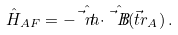Convert formula to latex. <formula><loc_0><loc_0><loc_500><loc_500>\hat { H } _ { A F } = - \hat { \vec { t } { m } } \cdot \hat { \vec { t } { B } } ( \vec { t } { r } _ { A } ) \, .</formula> 